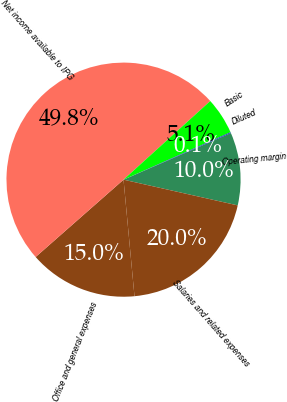<chart> <loc_0><loc_0><loc_500><loc_500><pie_chart><fcel>Operating margin<fcel>Salaries and related expenses<fcel>Office and general expenses<fcel>Net income available to IPG<fcel>Basic<fcel>Diluted<nl><fcel>10.05%<fcel>19.98%<fcel>15.01%<fcel>49.76%<fcel>5.08%<fcel>0.12%<nl></chart> 